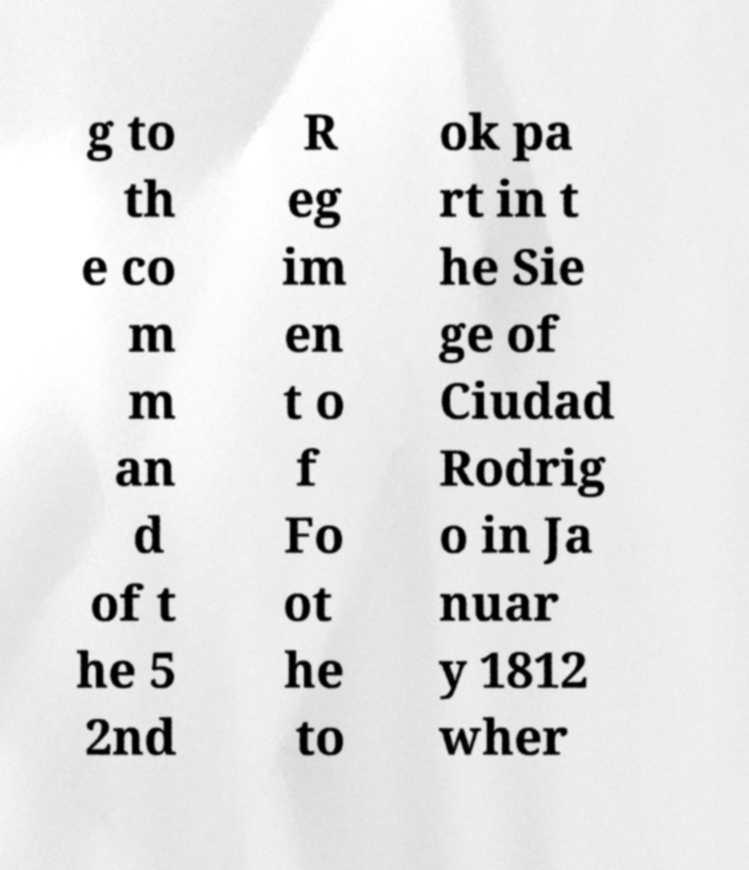There's text embedded in this image that I need extracted. Can you transcribe it verbatim? g to th e co m m an d of t he 5 2nd R eg im en t o f Fo ot he to ok pa rt in t he Sie ge of Ciudad Rodrig o in Ja nuar y 1812 wher 